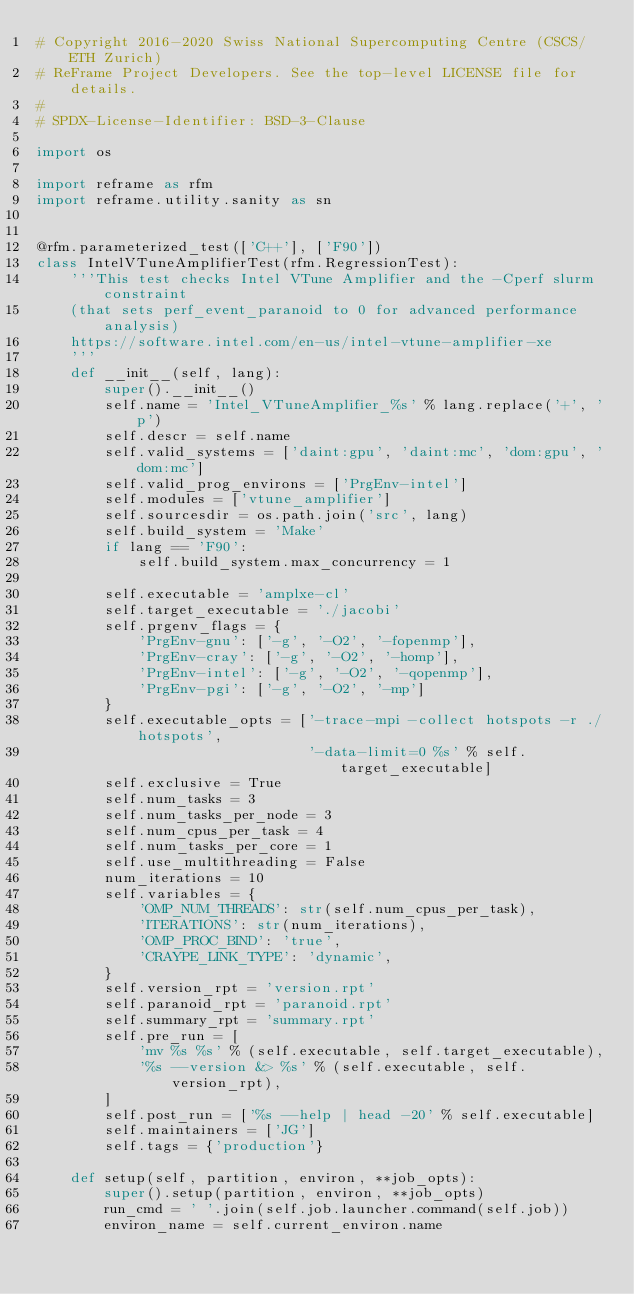Convert code to text. <code><loc_0><loc_0><loc_500><loc_500><_Python_># Copyright 2016-2020 Swiss National Supercomputing Centre (CSCS/ETH Zurich)
# ReFrame Project Developers. See the top-level LICENSE file for details.
#
# SPDX-License-Identifier: BSD-3-Clause

import os

import reframe as rfm
import reframe.utility.sanity as sn


@rfm.parameterized_test(['C++'], ['F90'])
class IntelVTuneAmplifierTest(rfm.RegressionTest):
    '''This test checks Intel VTune Amplifier and the -Cperf slurm constraint
    (that sets perf_event_paranoid to 0 for advanced performance analysis)
    https://software.intel.com/en-us/intel-vtune-amplifier-xe
    '''
    def __init__(self, lang):
        super().__init__()
        self.name = 'Intel_VTuneAmplifier_%s' % lang.replace('+', 'p')
        self.descr = self.name
        self.valid_systems = ['daint:gpu', 'daint:mc', 'dom:gpu', 'dom:mc']
        self.valid_prog_environs = ['PrgEnv-intel']
        self.modules = ['vtune_amplifier']
        self.sourcesdir = os.path.join('src', lang)
        self.build_system = 'Make'
        if lang == 'F90':
            self.build_system.max_concurrency = 1

        self.executable = 'amplxe-cl'
        self.target_executable = './jacobi'
        self.prgenv_flags = {
            'PrgEnv-gnu': ['-g', '-O2', '-fopenmp'],
            'PrgEnv-cray': ['-g', '-O2', '-homp'],
            'PrgEnv-intel': ['-g', '-O2', '-qopenmp'],
            'PrgEnv-pgi': ['-g', '-O2', '-mp']
        }
        self.executable_opts = ['-trace-mpi -collect hotspots -r ./hotspots',
                                '-data-limit=0 %s' % self.target_executable]
        self.exclusive = True
        self.num_tasks = 3
        self.num_tasks_per_node = 3
        self.num_cpus_per_task = 4
        self.num_tasks_per_core = 1
        self.use_multithreading = False
        num_iterations = 10
        self.variables = {
            'OMP_NUM_THREADS': str(self.num_cpus_per_task),
            'ITERATIONS': str(num_iterations),
            'OMP_PROC_BIND': 'true',
            'CRAYPE_LINK_TYPE': 'dynamic',
        }
        self.version_rpt = 'version.rpt'
        self.paranoid_rpt = 'paranoid.rpt'
        self.summary_rpt = 'summary.rpt'
        self.pre_run = [
            'mv %s %s' % (self.executable, self.target_executable),
            '%s --version &> %s' % (self.executable, self.version_rpt),
        ]
        self.post_run = ['%s --help | head -20' % self.executable]
        self.maintainers = ['JG']
        self.tags = {'production'}

    def setup(self, partition, environ, **job_opts):
        super().setup(partition, environ, **job_opts)
        run_cmd = ' '.join(self.job.launcher.command(self.job))
        environ_name = self.current_environ.name</code> 